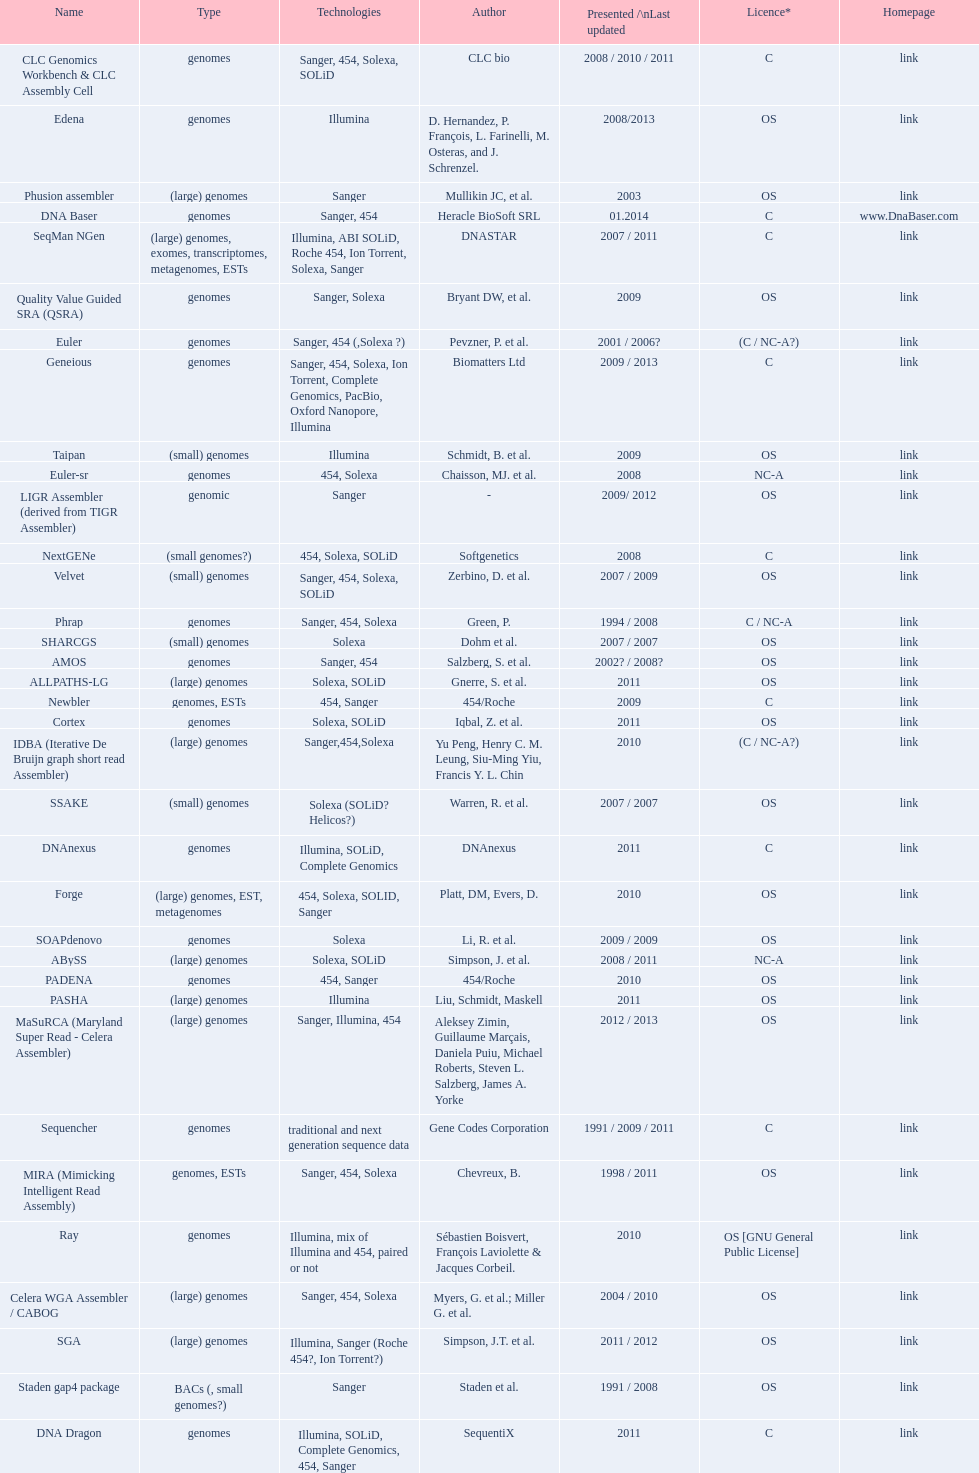When was the velvet last updated? 2009. Parse the table in full. {'header': ['Name', 'Type', 'Technologies', 'Author', 'Presented /\\nLast updated', 'Licence*', 'Homepage'], 'rows': [['CLC Genomics Workbench & CLC Assembly Cell', 'genomes', 'Sanger, 454, Solexa, SOLiD', 'CLC bio', '2008 / 2010 / 2011', 'C', 'link'], ['Edena', 'genomes', 'Illumina', 'D. Hernandez, P. François, L. Farinelli, M. Osteras, and J. Schrenzel.', '2008/2013', 'OS', 'link'], ['Phusion assembler', '(large) genomes', 'Sanger', 'Mullikin JC, et al.', '2003', 'OS', 'link'], ['DNA Baser', 'genomes', 'Sanger, 454', 'Heracle BioSoft SRL', '01.2014', 'C', 'www.DnaBaser.com'], ['SeqMan NGen', '(large) genomes, exomes, transcriptomes, metagenomes, ESTs', 'Illumina, ABI SOLiD, Roche 454, Ion Torrent, Solexa, Sanger', 'DNASTAR', '2007 / 2011', 'C', 'link'], ['Quality Value Guided SRA (QSRA)', 'genomes', 'Sanger, Solexa', 'Bryant DW, et al.', '2009', 'OS', 'link'], ['Euler', 'genomes', 'Sanger, 454 (,Solexa\xa0?)', 'Pevzner, P. et al.', '2001 / 2006?', '(C / NC-A?)', 'link'], ['Geneious', 'genomes', 'Sanger, 454, Solexa, Ion Torrent, Complete Genomics, PacBio, Oxford Nanopore, Illumina', 'Biomatters Ltd', '2009 / 2013', 'C', 'link'], ['Taipan', '(small) genomes', 'Illumina', 'Schmidt, B. et al.', '2009', 'OS', 'link'], ['Euler-sr', 'genomes', '454, Solexa', 'Chaisson, MJ. et al.', '2008', 'NC-A', 'link'], ['LIGR Assembler (derived from TIGR Assembler)', 'genomic', 'Sanger', '-', '2009/ 2012', 'OS', 'link'], ['NextGENe', '(small genomes?)', '454, Solexa, SOLiD', 'Softgenetics', '2008', 'C', 'link'], ['Velvet', '(small) genomes', 'Sanger, 454, Solexa, SOLiD', 'Zerbino, D. et al.', '2007 / 2009', 'OS', 'link'], ['Phrap', 'genomes', 'Sanger, 454, Solexa', 'Green, P.', '1994 / 2008', 'C / NC-A', 'link'], ['SHARCGS', '(small) genomes', 'Solexa', 'Dohm et al.', '2007 / 2007', 'OS', 'link'], ['AMOS', 'genomes', 'Sanger, 454', 'Salzberg, S. et al.', '2002? / 2008?', 'OS', 'link'], ['ALLPATHS-LG', '(large) genomes', 'Solexa, SOLiD', 'Gnerre, S. et al.', '2011', 'OS', 'link'], ['Newbler', 'genomes, ESTs', '454, Sanger', '454/Roche', '2009', 'C', 'link'], ['Cortex', 'genomes', 'Solexa, SOLiD', 'Iqbal, Z. et al.', '2011', 'OS', 'link'], ['IDBA (Iterative De Bruijn graph short read Assembler)', '(large) genomes', 'Sanger,454,Solexa', 'Yu Peng, Henry C. M. Leung, Siu-Ming Yiu, Francis Y. L. Chin', '2010', '(C / NC-A?)', 'link'], ['SSAKE', '(small) genomes', 'Solexa (SOLiD? Helicos?)', 'Warren, R. et al.', '2007 / 2007', 'OS', 'link'], ['DNAnexus', 'genomes', 'Illumina, SOLiD, Complete Genomics', 'DNAnexus', '2011', 'C', 'link'], ['Forge', '(large) genomes, EST, metagenomes', '454, Solexa, SOLID, Sanger', 'Platt, DM, Evers, D.', '2010', 'OS', 'link'], ['SOAPdenovo', 'genomes', 'Solexa', 'Li, R. et al.', '2009 / 2009', 'OS', 'link'], ['ABySS', '(large) genomes', 'Solexa, SOLiD', 'Simpson, J. et al.', '2008 / 2011', 'NC-A', 'link'], ['PADENA', 'genomes', '454, Sanger', '454/Roche', '2010', 'OS', 'link'], ['PASHA', '(large) genomes', 'Illumina', 'Liu, Schmidt, Maskell', '2011', 'OS', 'link'], ['MaSuRCA (Maryland Super Read - Celera Assembler)', '(large) genomes', 'Sanger, Illumina, 454', 'Aleksey Zimin, Guillaume Marçais, Daniela Puiu, Michael Roberts, Steven L. Salzberg, James A. Yorke', '2012 / 2013', 'OS', 'link'], ['Sequencher', 'genomes', 'traditional and next generation sequence data', 'Gene Codes Corporation', '1991 / 2009 / 2011', 'C', 'link'], ['MIRA (Mimicking Intelligent Read Assembly)', 'genomes, ESTs', 'Sanger, 454, Solexa', 'Chevreux, B.', '1998 / 2011', 'OS', 'link'], ['Ray', 'genomes', 'Illumina, mix of Illumina and 454, paired or not', 'Sébastien Boisvert, François Laviolette & Jacques Corbeil.', '2010', 'OS [GNU General Public License]', 'link'], ['Celera WGA Assembler / CABOG', '(large) genomes', 'Sanger, 454, Solexa', 'Myers, G. et al.; Miller G. et al.', '2004 / 2010', 'OS', 'link'], ['SGA', '(large) genomes', 'Illumina, Sanger (Roche 454?, Ion Torrent?)', 'Simpson, J.T. et al.', '2011 / 2012', 'OS', 'link'], ['Staden gap4 package', 'BACs (, small genomes?)', 'Sanger', 'Staden et al.', '1991 / 2008', 'OS', 'link'], ['DNA Dragon', 'genomes', 'Illumina, SOLiD, Complete Genomics, 454, Sanger', 'SequentiX', '2011', 'C', 'link'], ['SparseAssembler', '(large) genomes', 'Illumina, 454, Ion torrent', 'Ye, C. et al.', '2012 / 2012', 'OS', 'link'], ['Arapan-S', 'Small Genomes (Viruses and Bacteria)', 'All', 'Sahli, M. & Shibuya, T.', '2011 / 2012', 'OS', 'link'], ['TIGR Assembler', 'genomic', 'Sanger', '-', '1995 / 2003', 'OS', 'link'], ['SPAdes', '(small) genomes, single-cell', 'Illumina, Solexa', 'Bankevich, A et al.', '2012 / 2013', 'OS', 'link'], ['Arapan-M', 'Medium Genomes (e.g. E.coli)', 'All', 'Sahli, M. & Shibuya, T.', '2011 / 2012', 'OS', 'link'], ['Graph Constructor', '(large) genomes', 'Sanger, 454, Solexa, SOLiD', 'Convey Computer Corporation', '2011', 'C', 'link'], ['VCAKE', '(small) genomes', 'Solexa (SOLiD?, Helicos?)', 'Jeck, W. et al.', '2007 / 2007', 'OS', 'link'], ['SOPRA', 'genomes', 'Illumina, SOLiD, Sanger, 454', 'Dayarian, A. et al.', '2010 / 2011', 'OS', 'link']]} 